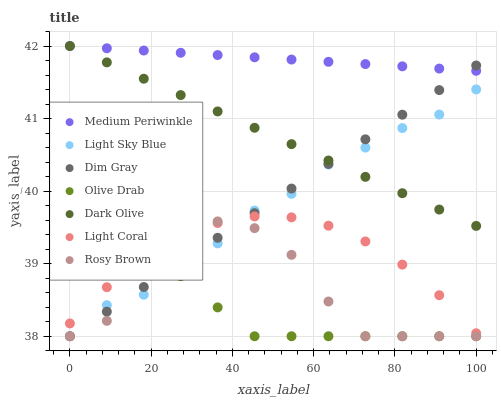Does Olive Drab have the minimum area under the curve?
Answer yes or no. Yes. Does Medium Periwinkle have the maximum area under the curve?
Answer yes or no. Yes. Does Dark Olive have the minimum area under the curve?
Answer yes or no. No. Does Dark Olive have the maximum area under the curve?
Answer yes or no. No. Is Medium Periwinkle the smoothest?
Answer yes or no. Yes. Is Rosy Brown the roughest?
Answer yes or no. Yes. Is Dark Olive the smoothest?
Answer yes or no. No. Is Dark Olive the roughest?
Answer yes or no. No. Does Dim Gray have the lowest value?
Answer yes or no. Yes. Does Dark Olive have the lowest value?
Answer yes or no. No. Does Medium Periwinkle have the highest value?
Answer yes or no. Yes. Does Light Coral have the highest value?
Answer yes or no. No. Is Light Sky Blue less than Medium Periwinkle?
Answer yes or no. Yes. Is Medium Periwinkle greater than Rosy Brown?
Answer yes or no. Yes. Does Olive Drab intersect Dim Gray?
Answer yes or no. Yes. Is Olive Drab less than Dim Gray?
Answer yes or no. No. Is Olive Drab greater than Dim Gray?
Answer yes or no. No. Does Light Sky Blue intersect Medium Periwinkle?
Answer yes or no. No. 